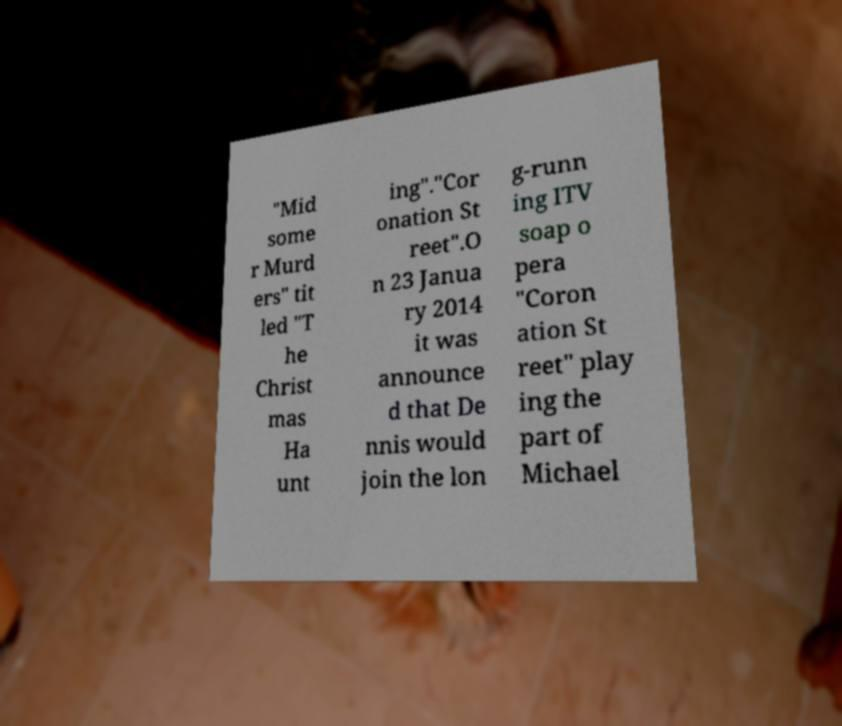Can you read and provide the text displayed in the image?This photo seems to have some interesting text. Can you extract and type it out for me? "Mid some r Murd ers" tit led "T he Christ mas Ha unt ing"."Cor onation St reet".O n 23 Janua ry 2014 it was announce d that De nnis would join the lon g-runn ing ITV soap o pera "Coron ation St reet" play ing the part of Michael 